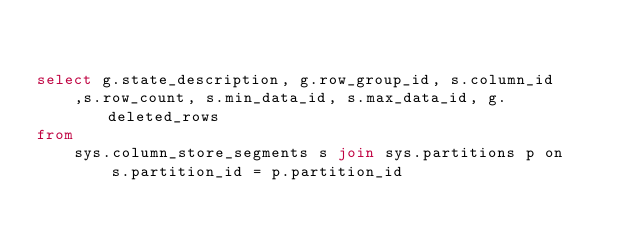Convert code to text. <code><loc_0><loc_0><loc_500><loc_500><_SQL_>

select g.state_description, g.row_group_id, s.column_id
    ,s.row_count, s.min_data_id, s.max_data_id, g.deleted_rows
from
    sys.column_store_segments s join sys.partitions p on
        s.partition_id = p.partition_id</code> 